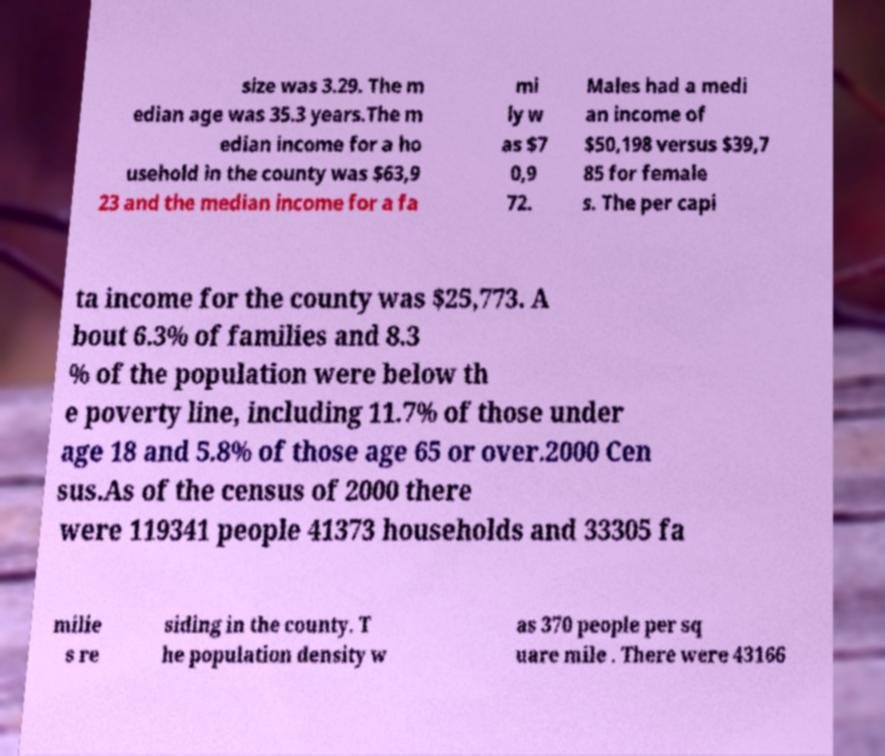Please read and relay the text visible in this image. What does it say? size was 3.29. The m edian age was 35.3 years.The m edian income for a ho usehold in the county was $63,9 23 and the median income for a fa mi ly w as $7 0,9 72. Males had a medi an income of $50,198 versus $39,7 85 for female s. The per capi ta income for the county was $25,773. A bout 6.3% of families and 8.3 % of the population were below th e poverty line, including 11.7% of those under age 18 and 5.8% of those age 65 or over.2000 Cen sus.As of the census of 2000 there were 119341 people 41373 households and 33305 fa milie s re siding in the county. T he population density w as 370 people per sq uare mile . There were 43166 